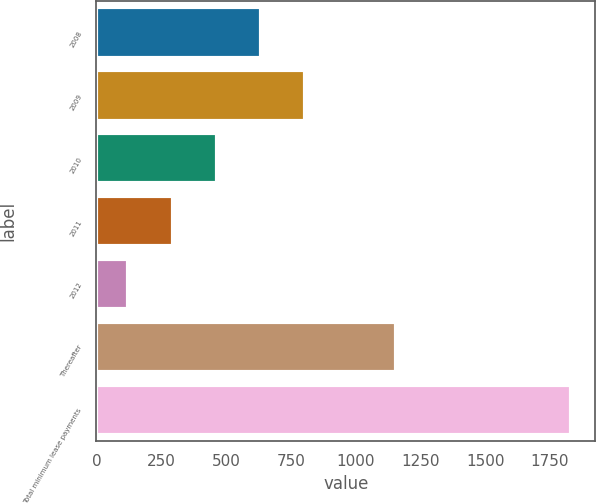<chart> <loc_0><loc_0><loc_500><loc_500><bar_chart><fcel>2008<fcel>2009<fcel>2010<fcel>2011<fcel>2012<fcel>Thereafter<fcel>Total minimum lease payments<nl><fcel>636<fcel>807<fcel>465<fcel>294<fcel>123<fcel>1156<fcel>1833<nl></chart> 